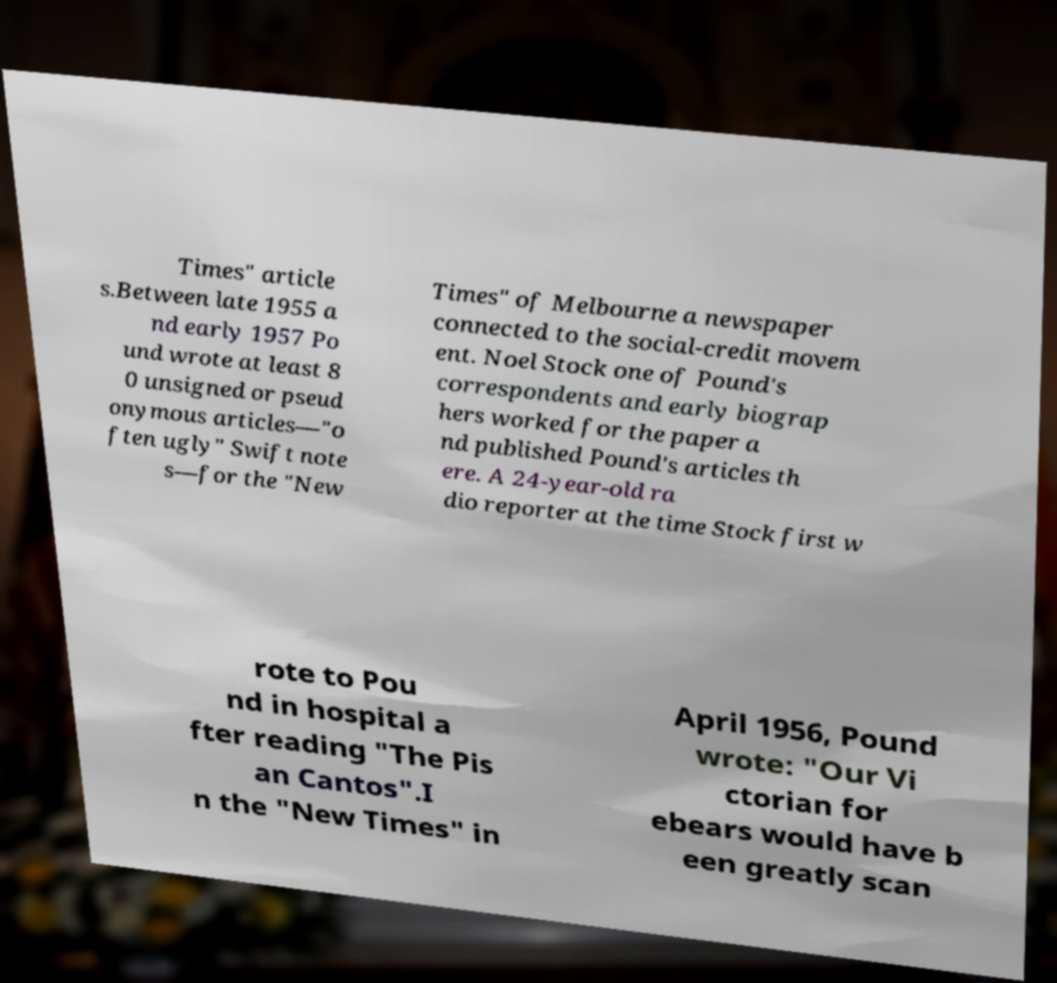Could you assist in decoding the text presented in this image and type it out clearly? Times" article s.Between late 1955 a nd early 1957 Po und wrote at least 8 0 unsigned or pseud onymous articles—"o ften ugly" Swift note s—for the "New Times" of Melbourne a newspaper connected to the social-credit movem ent. Noel Stock one of Pound's correspondents and early biograp hers worked for the paper a nd published Pound's articles th ere. A 24-year-old ra dio reporter at the time Stock first w rote to Pou nd in hospital a fter reading "The Pis an Cantos".I n the "New Times" in April 1956, Pound wrote: "Our Vi ctorian for ebears would have b een greatly scan 